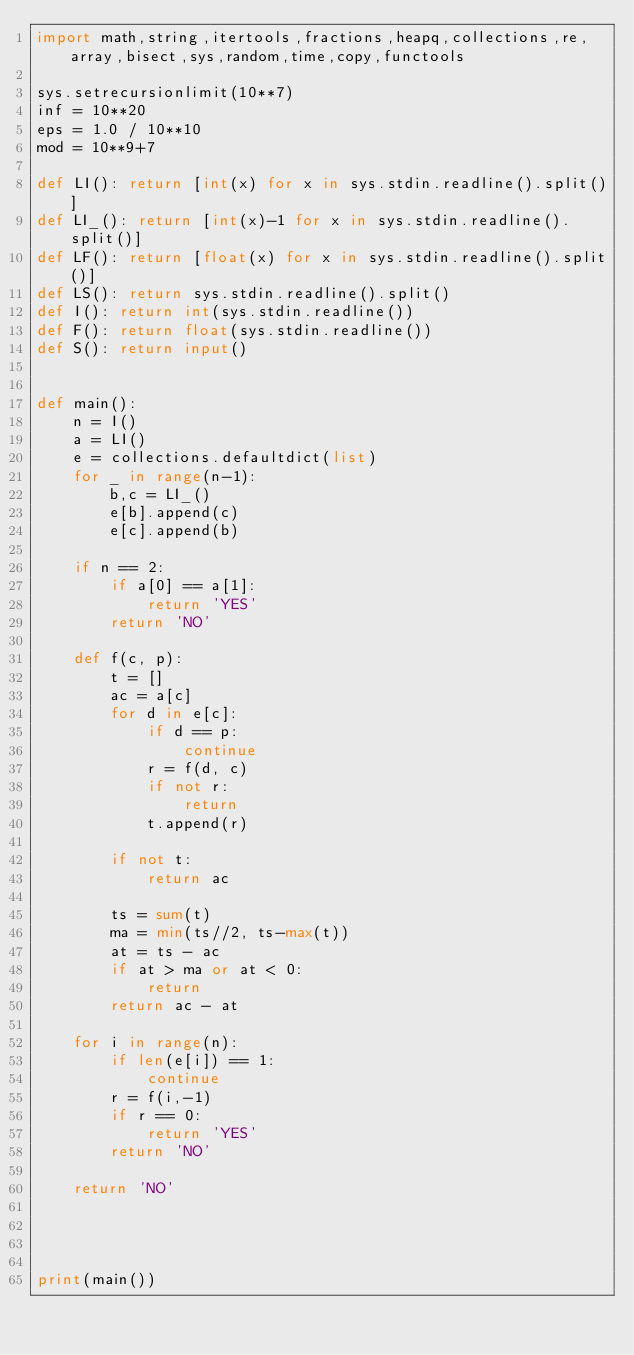Convert code to text. <code><loc_0><loc_0><loc_500><loc_500><_Python_>import math,string,itertools,fractions,heapq,collections,re,array,bisect,sys,random,time,copy,functools

sys.setrecursionlimit(10**7)
inf = 10**20
eps = 1.0 / 10**10
mod = 10**9+7

def LI(): return [int(x) for x in sys.stdin.readline().split()]
def LI_(): return [int(x)-1 for x in sys.stdin.readline().split()]
def LF(): return [float(x) for x in sys.stdin.readline().split()]
def LS(): return sys.stdin.readline().split()
def I(): return int(sys.stdin.readline())
def F(): return float(sys.stdin.readline())
def S(): return input()


def main():
    n = I()
    a = LI()
    e = collections.defaultdict(list)
    for _ in range(n-1):
        b,c = LI_()
        e[b].append(c)
        e[c].append(b)

    if n == 2:
        if a[0] == a[1]:
            return 'YES'
        return 'NO'

    def f(c, p):
        t = []
        ac = a[c]
        for d in e[c]:
            if d == p:
                continue
            r = f(d, c)
            if not r:
                return
            t.append(r)

        if not t:
            return ac

        ts = sum(t)
        ma = min(ts//2, ts-max(t))
        at = ts - ac
        if at > ma or at < 0:
            return
        return ac - at

    for i in range(n):
        if len(e[i]) == 1:
            continue
        r = f(i,-1)
        if r == 0:
            return 'YES'
        return 'NO'

    return 'NO'




print(main())




</code> 